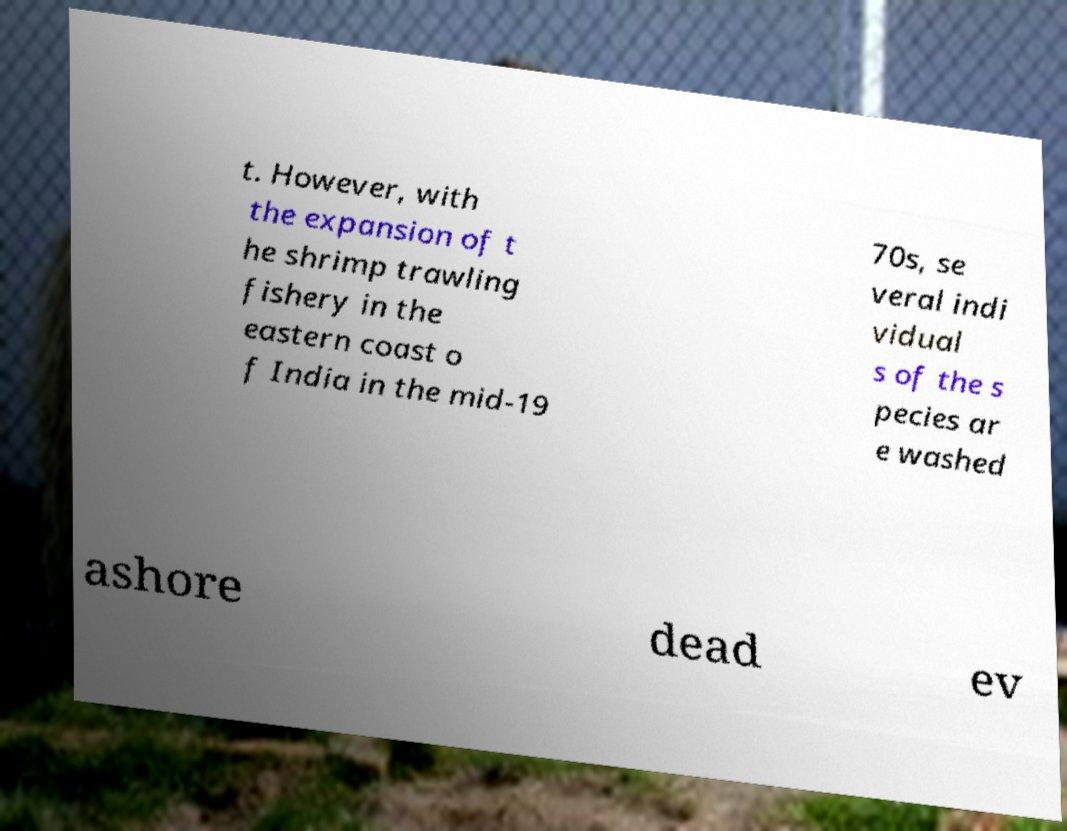Please identify and transcribe the text found in this image. t. However, with the expansion of t he shrimp trawling fishery in the eastern coast o f India in the mid-19 70s, se veral indi vidual s of the s pecies ar e washed ashore dead ev 